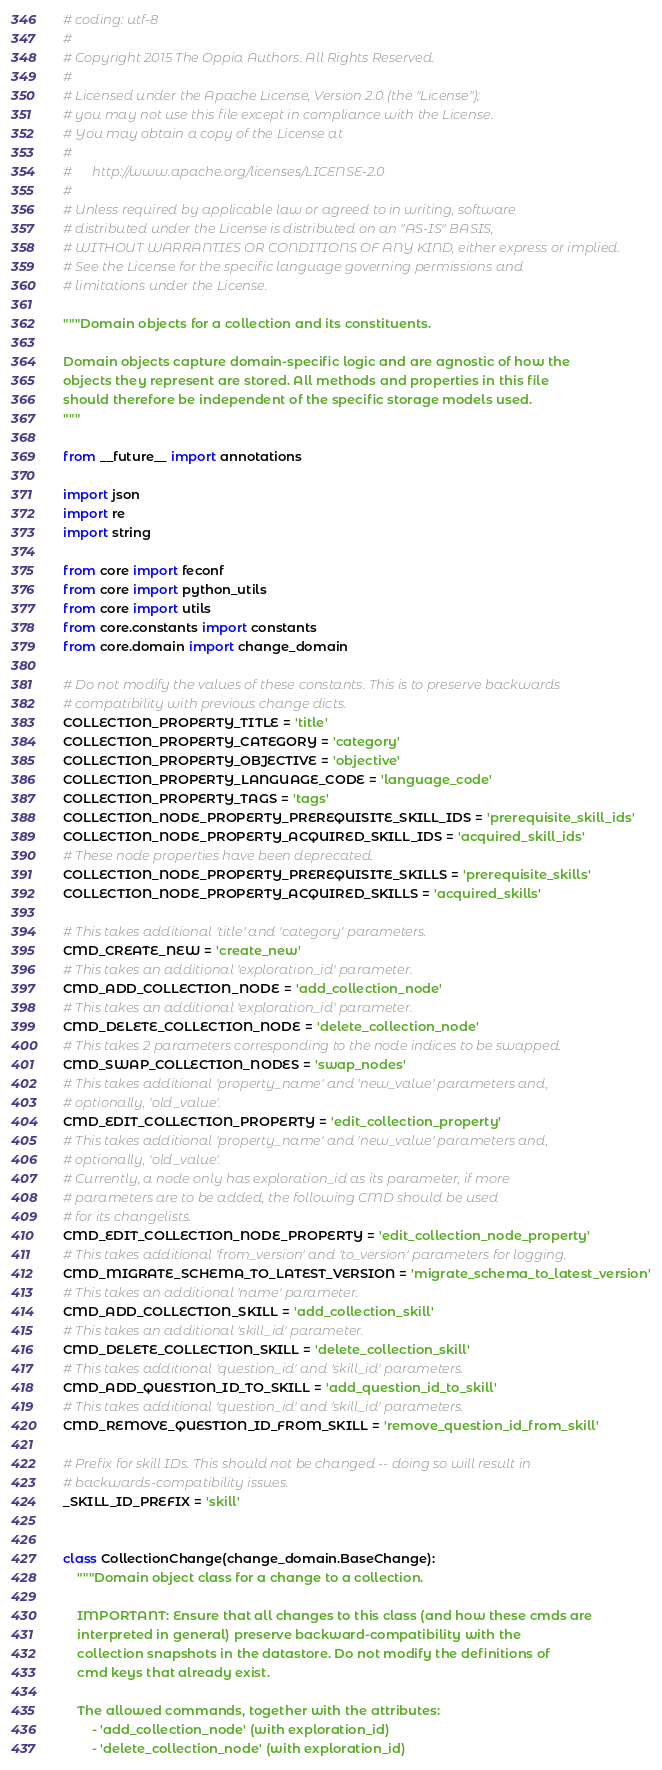<code> <loc_0><loc_0><loc_500><loc_500><_Python_># coding: utf-8
#
# Copyright 2015 The Oppia Authors. All Rights Reserved.
#
# Licensed under the Apache License, Version 2.0 (the "License");
# you may not use this file except in compliance with the License.
# You may obtain a copy of the License at
#
#      http://www.apache.org/licenses/LICENSE-2.0
#
# Unless required by applicable law or agreed to in writing, software
# distributed under the License is distributed on an "AS-IS" BASIS,
# WITHOUT WARRANTIES OR CONDITIONS OF ANY KIND, either express or implied.
# See the License for the specific language governing permissions and
# limitations under the License.

"""Domain objects for a collection and its constituents.

Domain objects capture domain-specific logic and are agnostic of how the
objects they represent are stored. All methods and properties in this file
should therefore be independent of the specific storage models used.
"""

from __future__ import annotations

import json
import re
import string

from core import feconf
from core import python_utils
from core import utils
from core.constants import constants
from core.domain import change_domain

# Do not modify the values of these constants. This is to preserve backwards
# compatibility with previous change dicts.
COLLECTION_PROPERTY_TITLE = 'title'
COLLECTION_PROPERTY_CATEGORY = 'category'
COLLECTION_PROPERTY_OBJECTIVE = 'objective'
COLLECTION_PROPERTY_LANGUAGE_CODE = 'language_code'
COLLECTION_PROPERTY_TAGS = 'tags'
COLLECTION_NODE_PROPERTY_PREREQUISITE_SKILL_IDS = 'prerequisite_skill_ids'
COLLECTION_NODE_PROPERTY_ACQUIRED_SKILL_IDS = 'acquired_skill_ids'
# These node properties have been deprecated.
COLLECTION_NODE_PROPERTY_PREREQUISITE_SKILLS = 'prerequisite_skills'
COLLECTION_NODE_PROPERTY_ACQUIRED_SKILLS = 'acquired_skills'

# This takes additional 'title' and 'category' parameters.
CMD_CREATE_NEW = 'create_new'
# This takes an additional 'exploration_id' parameter.
CMD_ADD_COLLECTION_NODE = 'add_collection_node'
# This takes an additional 'exploration_id' parameter.
CMD_DELETE_COLLECTION_NODE = 'delete_collection_node'
# This takes 2 parameters corresponding to the node indices to be swapped.
CMD_SWAP_COLLECTION_NODES = 'swap_nodes'
# This takes additional 'property_name' and 'new_value' parameters and,
# optionally, 'old_value'.
CMD_EDIT_COLLECTION_PROPERTY = 'edit_collection_property'
# This takes additional 'property_name' and 'new_value' parameters and,
# optionally, 'old_value'.
# Currently, a node only has exploration_id as its parameter, if more
# parameters are to be added, the following CMD should be used
# for its changelists.
CMD_EDIT_COLLECTION_NODE_PROPERTY = 'edit_collection_node_property'
# This takes additional 'from_version' and 'to_version' parameters for logging.
CMD_MIGRATE_SCHEMA_TO_LATEST_VERSION = 'migrate_schema_to_latest_version'
# This takes an additional 'name' parameter.
CMD_ADD_COLLECTION_SKILL = 'add_collection_skill'
# This takes an additional 'skill_id' parameter.
CMD_DELETE_COLLECTION_SKILL = 'delete_collection_skill'
# This takes additional 'question_id' and 'skill_id' parameters.
CMD_ADD_QUESTION_ID_TO_SKILL = 'add_question_id_to_skill'
# This takes additional 'question_id' and 'skill_id' parameters.
CMD_REMOVE_QUESTION_ID_FROM_SKILL = 'remove_question_id_from_skill'

# Prefix for skill IDs. This should not be changed -- doing so will result in
# backwards-compatibility issues.
_SKILL_ID_PREFIX = 'skill'


class CollectionChange(change_domain.BaseChange):
    """Domain object class for a change to a collection.

    IMPORTANT: Ensure that all changes to this class (and how these cmds are
    interpreted in general) preserve backward-compatibility with the
    collection snapshots in the datastore. Do not modify the definitions of
    cmd keys that already exist.

    The allowed commands, together with the attributes:
        - 'add_collection_node' (with exploration_id)
        - 'delete_collection_node' (with exploration_id)</code> 